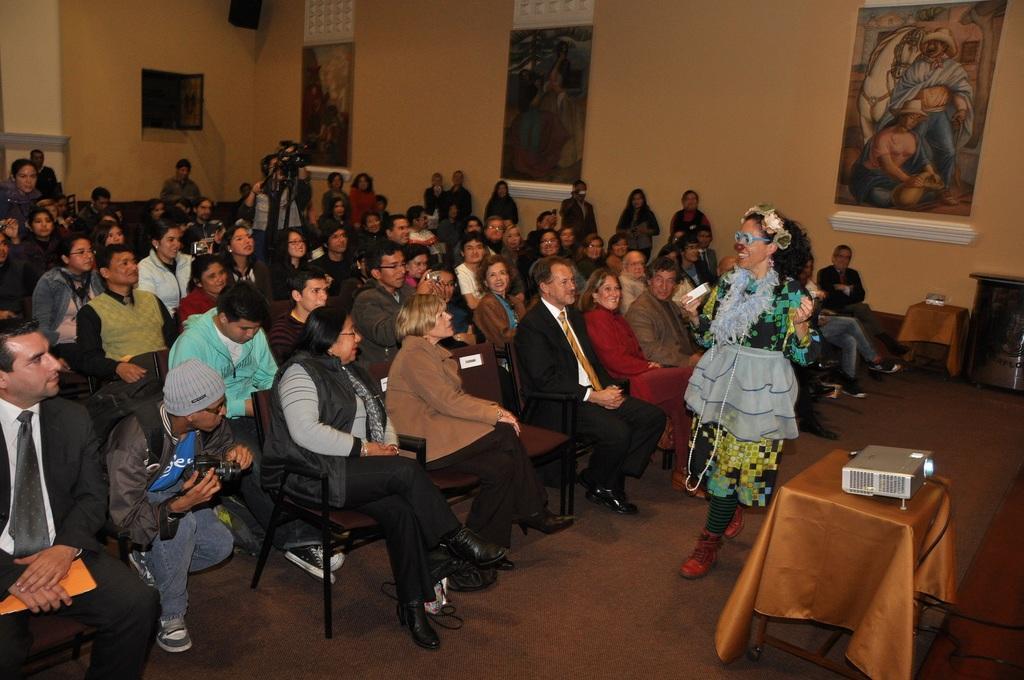How would you summarize this image in a sentence or two? There is a room. There is a group of people. They are sitting on a chairs. Some persons are standing. There is a table. On the left side we have a person. He is sitting like squat position. He is wearing a cap. He is holding a camera ,We can see in background posters ,wall 